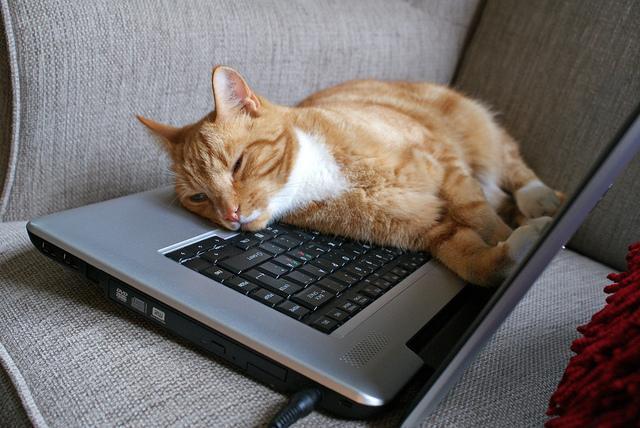Why is the cat likely sleeping on the laptop?
Choose the right answer and clarify with the format: 'Answer: answer
Rationale: rationale.'
Options: Attention, unknown, work, heat. Answer: heat.
Rationale: The laptop is warm for him to sleep on. 